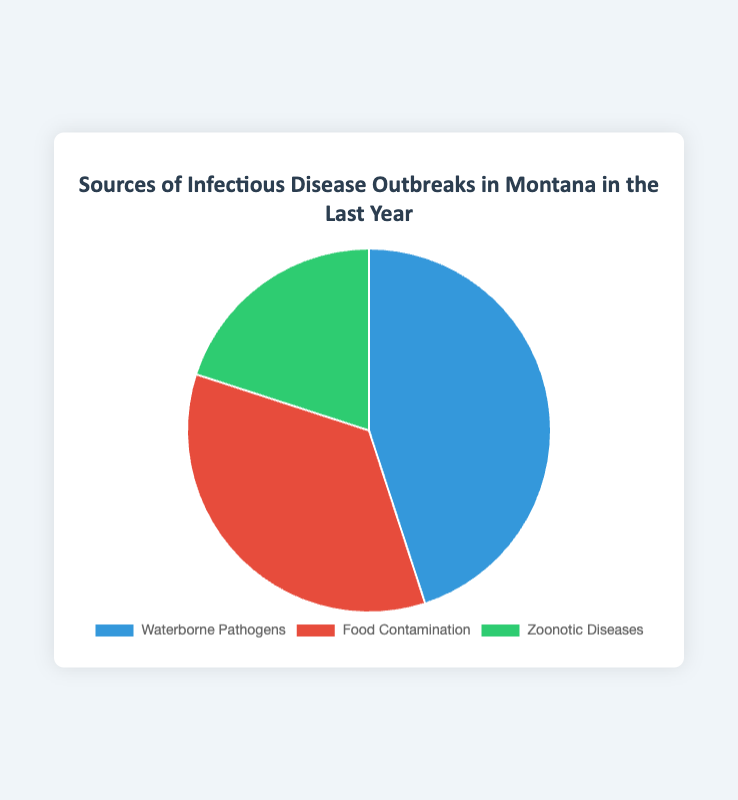What percentage of infectious disease outbreaks in Montana in the last year were due to Waterborne Pathogens? According to the figure, Waterborne Pathogens were responsible for 45% of the infectious disease outbreaks in Montana in the last year.
Answer: 45% Which source contributed the least to infectious disease outbreaks in Montana in the last year? The figure shows that Zoonotic Diseases contributed 20%, which is the smallest percentage among the three sources.
Answer: Zoonotic Diseases How much greater is the percentage of outbreaks caused by Waterborne Pathogens compared to Zoonotic Diseases? The percentage for Waterborne Pathogens is 45%, and for Zoonotic Diseases, it is 20%. The difference is 45% - 20% = 25%.
Answer: 25% What is the combined percentage of outbreaks caused by Food Contamination and Zoonotic Diseases? The figure shows that Food Contamination is responsible for 35% and Zoonotic Diseases for 20%. The combined percentage is 35% + 20% = 55%.
Answer: 55% Which source of infectious disease outbreaks is represented by the red section of the pie chart, and what percentage does it account for? The red section of the pie chart represents Food Contamination, which accounts for 35% of the outbreaks.
Answer: Food Contamination, 35% What fraction of the outbreaks were due to Waterborne Pathogens? Waterborne Pathogens accounted for 45% of the outbreaks, which is equivalent to 45/100 or simplified to 9/20.
Answer: 9/20 Compare the percentages of outbreaks caused by Food Contamination and Zoonotic Diseases. Which is higher and by how much? Food Contamination accounts for 35% and Zoonotic Diseases for 20%. Food Contamination is higher by 35% - 20% = 15%.
Answer: Food Contamination, 15% If we consider only the outbreaks caused by Food Contamination and Zoonotic Diseases, what percentage of these outbreaks is due to Food Contamination? The combined percentage of Food Contamination and Zoonotic Diseases is 55% (35% + 20%). The proportion of outbreaks due to Food Contamination among these is (35/55) * 100 ≈ 63.64%.
Answer: 63.64% What is the percentage difference between the most and the least common sources of infectious disease outbreaks? The most common source is Waterborne Pathogens at 45%, and the least common is Zoonotic Diseases at 20%. The percentage difference is 45% - 20% = 25%.
Answer: 25% 